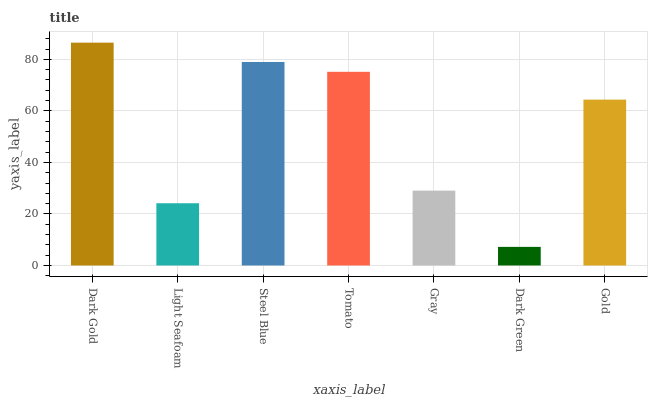Is Dark Green the minimum?
Answer yes or no. Yes. Is Dark Gold the maximum?
Answer yes or no. Yes. Is Light Seafoam the minimum?
Answer yes or no. No. Is Light Seafoam the maximum?
Answer yes or no. No. Is Dark Gold greater than Light Seafoam?
Answer yes or no. Yes. Is Light Seafoam less than Dark Gold?
Answer yes or no. Yes. Is Light Seafoam greater than Dark Gold?
Answer yes or no. No. Is Dark Gold less than Light Seafoam?
Answer yes or no. No. Is Gold the high median?
Answer yes or no. Yes. Is Gold the low median?
Answer yes or no. Yes. Is Tomato the high median?
Answer yes or no. No. Is Gray the low median?
Answer yes or no. No. 